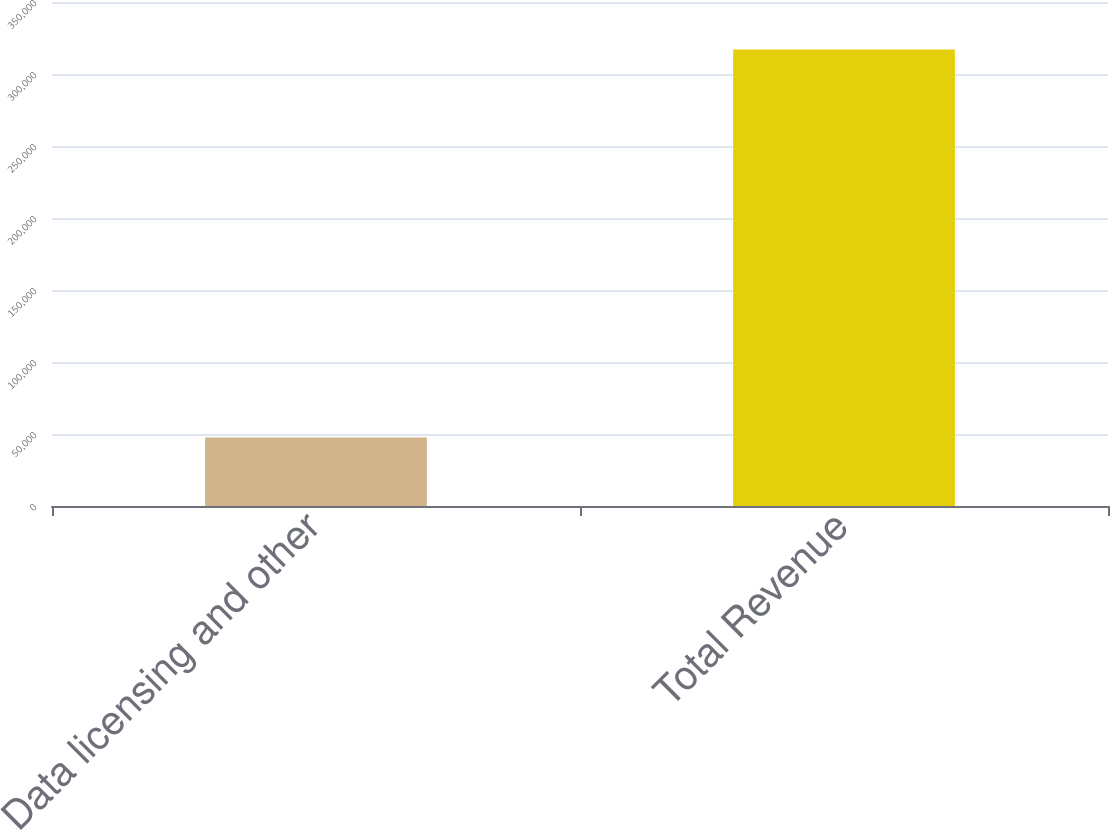<chart> <loc_0><loc_0><loc_500><loc_500><bar_chart><fcel>Data licensing and other<fcel>Total Revenue<nl><fcel>47512<fcel>316933<nl></chart> 